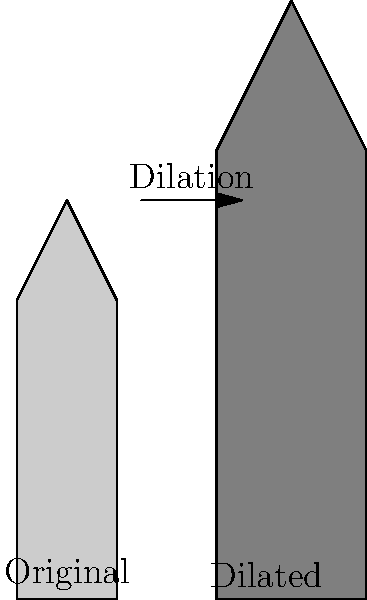A renowned football championship trophy is being redesigned. The original trophy design has a height of 40 cm and a base width of 10 cm. If the trophy undergoes a dilation with a scale factor of 1.5, what will be the new height-to-width ratio of the trophy? How does this compare to the original ratio? Let's approach this step-by-step:

1) First, let's calculate the original height-to-width ratio:
   Original ratio = $\frac{\text{height}}{\text{width}} = \frac{40 \text{ cm}}{10 \text{ cm}} = 4:1$

2) Now, let's consider the effects of dilation:
   - When an object undergoes dilation, all dimensions are multiplied by the scale factor.
   - In this case, the scale factor is 1.5.

3) Calculate the new dimensions:
   - New height = $40 \text{ cm} \times 1.5 = 60 \text{ cm}$
   - New width = $10 \text{ cm} \times 1.5 = 15 \text{ cm}$

4) Calculate the new height-to-width ratio:
   New ratio = $\frac{\text{new height}}{\text{new width}} = \frac{60 \text{ cm}}{15 \text{ cm}} = 4:1$

5) Compare the ratios:
   - Original ratio: 4:1
   - New ratio: 4:1

6) Conclusion:
   The height-to-width ratio remains unchanged at 4:1 after dilation.

This demonstrates a key property of dilation: it preserves the proportions of the original figure. While the absolute dimensions have increased, the relative proportions remain the same.
Answer: 4:1, unchanged 